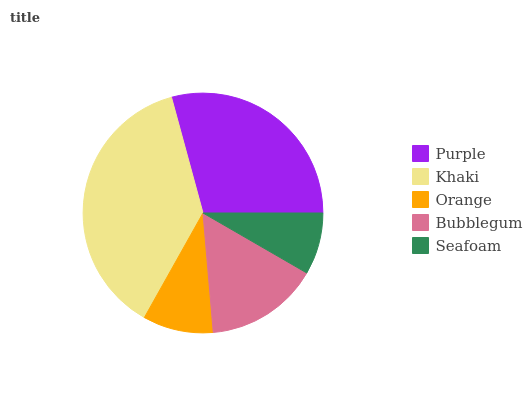Is Seafoam the minimum?
Answer yes or no. Yes. Is Khaki the maximum?
Answer yes or no. Yes. Is Orange the minimum?
Answer yes or no. No. Is Orange the maximum?
Answer yes or no. No. Is Khaki greater than Orange?
Answer yes or no. Yes. Is Orange less than Khaki?
Answer yes or no. Yes. Is Orange greater than Khaki?
Answer yes or no. No. Is Khaki less than Orange?
Answer yes or no. No. Is Bubblegum the high median?
Answer yes or no. Yes. Is Bubblegum the low median?
Answer yes or no. Yes. Is Purple the high median?
Answer yes or no. No. Is Khaki the low median?
Answer yes or no. No. 